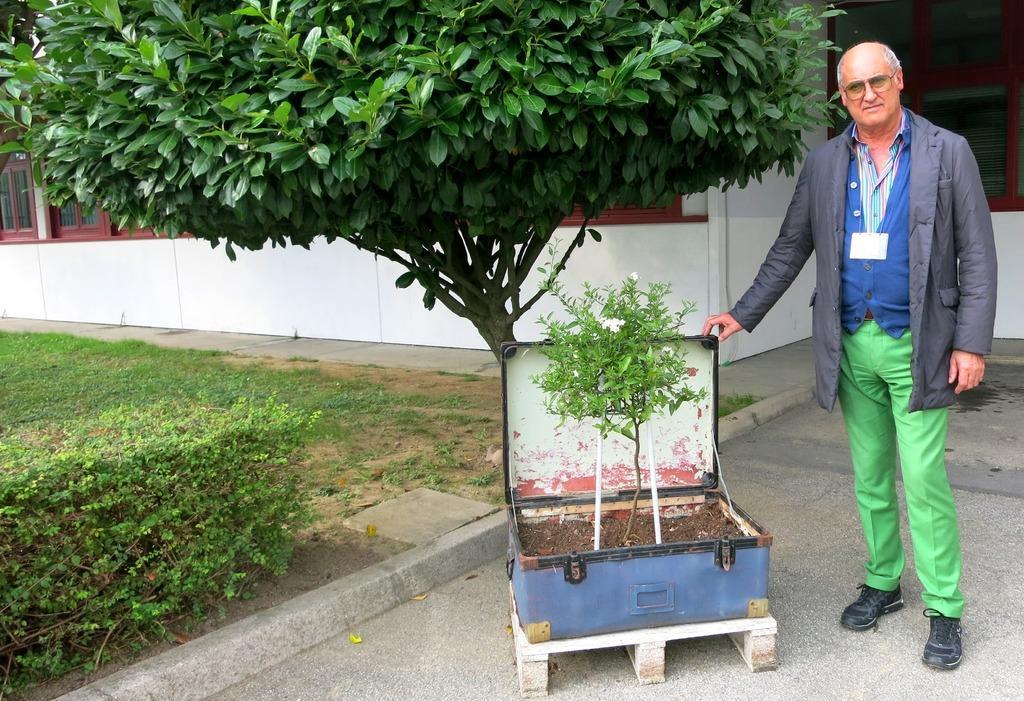Can you describe this image briefly? In the image we can see there is a man who standing and there is a suitcase in which there is a plant grown in it. Beside the ground is covered with grass and there is a tree. Behind there is a building. 